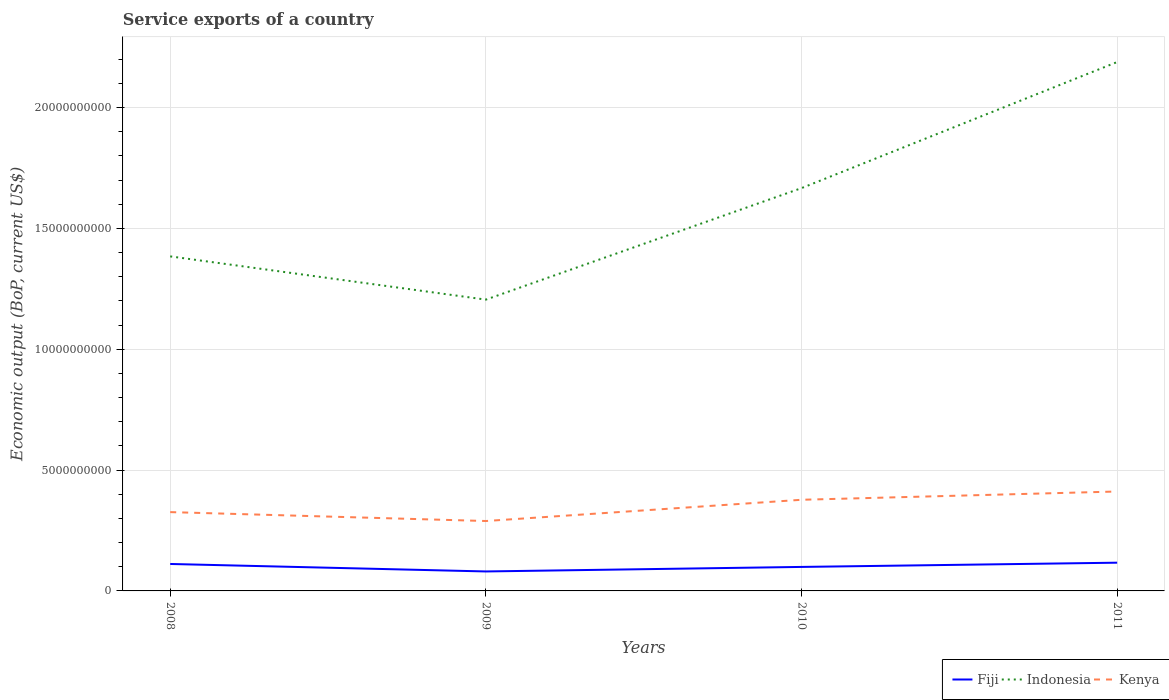Across all years, what is the maximum service exports in Indonesia?
Make the answer very short. 1.21e+1. In which year was the service exports in Kenya maximum?
Give a very brief answer. 2009. What is the total service exports in Fiji in the graph?
Provide a short and direct response. 3.09e+08. What is the difference between the highest and the second highest service exports in Fiji?
Your answer should be compact. 3.63e+08. What is the difference between two consecutive major ticks on the Y-axis?
Provide a short and direct response. 5.00e+09. How many legend labels are there?
Keep it short and to the point. 3. How are the legend labels stacked?
Give a very brief answer. Horizontal. What is the title of the graph?
Make the answer very short. Service exports of a country. Does "Nigeria" appear as one of the legend labels in the graph?
Your answer should be compact. No. What is the label or title of the X-axis?
Offer a terse response. Years. What is the label or title of the Y-axis?
Provide a succinct answer. Economic output (BoP, current US$). What is the Economic output (BoP, current US$) of Fiji in 2008?
Your answer should be compact. 1.12e+09. What is the Economic output (BoP, current US$) of Indonesia in 2008?
Your answer should be compact. 1.38e+1. What is the Economic output (BoP, current US$) of Kenya in 2008?
Give a very brief answer. 3.26e+09. What is the Economic output (BoP, current US$) of Fiji in 2009?
Offer a very short reply. 8.06e+08. What is the Economic output (BoP, current US$) of Indonesia in 2009?
Your answer should be compact. 1.21e+1. What is the Economic output (BoP, current US$) in Kenya in 2009?
Ensure brevity in your answer.  2.89e+09. What is the Economic output (BoP, current US$) in Fiji in 2010?
Keep it short and to the point. 9.93e+08. What is the Economic output (BoP, current US$) in Indonesia in 2010?
Offer a very short reply. 1.67e+1. What is the Economic output (BoP, current US$) in Kenya in 2010?
Offer a terse response. 3.77e+09. What is the Economic output (BoP, current US$) of Fiji in 2011?
Offer a terse response. 1.17e+09. What is the Economic output (BoP, current US$) of Indonesia in 2011?
Make the answer very short. 2.19e+1. What is the Economic output (BoP, current US$) in Kenya in 2011?
Your answer should be compact. 4.11e+09. Across all years, what is the maximum Economic output (BoP, current US$) of Fiji?
Your answer should be very brief. 1.17e+09. Across all years, what is the maximum Economic output (BoP, current US$) of Indonesia?
Give a very brief answer. 2.19e+1. Across all years, what is the maximum Economic output (BoP, current US$) in Kenya?
Provide a short and direct response. 4.11e+09. Across all years, what is the minimum Economic output (BoP, current US$) in Fiji?
Make the answer very short. 8.06e+08. Across all years, what is the minimum Economic output (BoP, current US$) in Indonesia?
Keep it short and to the point. 1.21e+1. Across all years, what is the minimum Economic output (BoP, current US$) of Kenya?
Provide a succinct answer. 2.89e+09. What is the total Economic output (BoP, current US$) of Fiji in the graph?
Ensure brevity in your answer.  4.08e+09. What is the total Economic output (BoP, current US$) of Indonesia in the graph?
Offer a very short reply. 6.45e+1. What is the total Economic output (BoP, current US$) in Kenya in the graph?
Ensure brevity in your answer.  1.40e+1. What is the difference between the Economic output (BoP, current US$) of Fiji in 2008 and that in 2009?
Offer a terse response. 3.09e+08. What is the difference between the Economic output (BoP, current US$) of Indonesia in 2008 and that in 2009?
Provide a succinct answer. 1.79e+09. What is the difference between the Economic output (BoP, current US$) of Kenya in 2008 and that in 2009?
Your answer should be very brief. 3.69e+08. What is the difference between the Economic output (BoP, current US$) of Fiji in 2008 and that in 2010?
Provide a short and direct response. 1.22e+08. What is the difference between the Economic output (BoP, current US$) in Indonesia in 2008 and that in 2010?
Provide a succinct answer. -2.83e+09. What is the difference between the Economic output (BoP, current US$) of Kenya in 2008 and that in 2010?
Offer a terse response. -5.10e+08. What is the difference between the Economic output (BoP, current US$) in Fiji in 2008 and that in 2011?
Ensure brevity in your answer.  -5.33e+07. What is the difference between the Economic output (BoP, current US$) in Indonesia in 2008 and that in 2011?
Offer a very short reply. -8.04e+09. What is the difference between the Economic output (BoP, current US$) in Kenya in 2008 and that in 2011?
Your response must be concise. -8.53e+08. What is the difference between the Economic output (BoP, current US$) of Fiji in 2009 and that in 2010?
Provide a short and direct response. -1.88e+08. What is the difference between the Economic output (BoP, current US$) in Indonesia in 2009 and that in 2010?
Ensure brevity in your answer.  -4.61e+09. What is the difference between the Economic output (BoP, current US$) in Kenya in 2009 and that in 2010?
Keep it short and to the point. -8.79e+08. What is the difference between the Economic output (BoP, current US$) of Fiji in 2009 and that in 2011?
Provide a succinct answer. -3.63e+08. What is the difference between the Economic output (BoP, current US$) in Indonesia in 2009 and that in 2011?
Ensure brevity in your answer.  -9.83e+09. What is the difference between the Economic output (BoP, current US$) in Kenya in 2009 and that in 2011?
Your answer should be very brief. -1.22e+09. What is the difference between the Economic output (BoP, current US$) of Fiji in 2010 and that in 2011?
Your answer should be very brief. -1.75e+08. What is the difference between the Economic output (BoP, current US$) in Indonesia in 2010 and that in 2011?
Your answer should be compact. -5.22e+09. What is the difference between the Economic output (BoP, current US$) in Kenya in 2010 and that in 2011?
Your response must be concise. -3.42e+08. What is the difference between the Economic output (BoP, current US$) of Fiji in 2008 and the Economic output (BoP, current US$) of Indonesia in 2009?
Provide a succinct answer. -1.09e+1. What is the difference between the Economic output (BoP, current US$) of Fiji in 2008 and the Economic output (BoP, current US$) of Kenya in 2009?
Make the answer very short. -1.78e+09. What is the difference between the Economic output (BoP, current US$) of Indonesia in 2008 and the Economic output (BoP, current US$) of Kenya in 2009?
Keep it short and to the point. 1.10e+1. What is the difference between the Economic output (BoP, current US$) of Fiji in 2008 and the Economic output (BoP, current US$) of Indonesia in 2010?
Make the answer very short. -1.56e+1. What is the difference between the Economic output (BoP, current US$) in Fiji in 2008 and the Economic output (BoP, current US$) in Kenya in 2010?
Your answer should be compact. -2.66e+09. What is the difference between the Economic output (BoP, current US$) in Indonesia in 2008 and the Economic output (BoP, current US$) in Kenya in 2010?
Make the answer very short. 1.01e+1. What is the difference between the Economic output (BoP, current US$) in Fiji in 2008 and the Economic output (BoP, current US$) in Indonesia in 2011?
Offer a terse response. -2.08e+1. What is the difference between the Economic output (BoP, current US$) in Fiji in 2008 and the Economic output (BoP, current US$) in Kenya in 2011?
Your response must be concise. -3.00e+09. What is the difference between the Economic output (BoP, current US$) of Indonesia in 2008 and the Economic output (BoP, current US$) of Kenya in 2011?
Ensure brevity in your answer.  9.73e+09. What is the difference between the Economic output (BoP, current US$) of Fiji in 2009 and the Economic output (BoP, current US$) of Indonesia in 2010?
Your answer should be compact. -1.59e+1. What is the difference between the Economic output (BoP, current US$) of Fiji in 2009 and the Economic output (BoP, current US$) of Kenya in 2010?
Offer a very short reply. -2.97e+09. What is the difference between the Economic output (BoP, current US$) of Indonesia in 2009 and the Economic output (BoP, current US$) of Kenya in 2010?
Provide a succinct answer. 8.28e+09. What is the difference between the Economic output (BoP, current US$) of Fiji in 2009 and the Economic output (BoP, current US$) of Indonesia in 2011?
Your answer should be very brief. -2.11e+1. What is the difference between the Economic output (BoP, current US$) of Fiji in 2009 and the Economic output (BoP, current US$) of Kenya in 2011?
Offer a very short reply. -3.31e+09. What is the difference between the Economic output (BoP, current US$) in Indonesia in 2009 and the Economic output (BoP, current US$) in Kenya in 2011?
Provide a succinct answer. 7.94e+09. What is the difference between the Economic output (BoP, current US$) in Fiji in 2010 and the Economic output (BoP, current US$) in Indonesia in 2011?
Your answer should be compact. -2.09e+1. What is the difference between the Economic output (BoP, current US$) in Fiji in 2010 and the Economic output (BoP, current US$) in Kenya in 2011?
Offer a terse response. -3.12e+09. What is the difference between the Economic output (BoP, current US$) of Indonesia in 2010 and the Economic output (BoP, current US$) of Kenya in 2011?
Your answer should be very brief. 1.26e+1. What is the average Economic output (BoP, current US$) of Fiji per year?
Provide a succinct answer. 1.02e+09. What is the average Economic output (BoP, current US$) in Indonesia per year?
Provide a short and direct response. 1.61e+1. What is the average Economic output (BoP, current US$) in Kenya per year?
Your answer should be compact. 3.51e+09. In the year 2008, what is the difference between the Economic output (BoP, current US$) in Fiji and Economic output (BoP, current US$) in Indonesia?
Keep it short and to the point. -1.27e+1. In the year 2008, what is the difference between the Economic output (BoP, current US$) of Fiji and Economic output (BoP, current US$) of Kenya?
Provide a succinct answer. -2.15e+09. In the year 2008, what is the difference between the Economic output (BoP, current US$) in Indonesia and Economic output (BoP, current US$) in Kenya?
Offer a very short reply. 1.06e+1. In the year 2009, what is the difference between the Economic output (BoP, current US$) in Fiji and Economic output (BoP, current US$) in Indonesia?
Provide a short and direct response. -1.12e+1. In the year 2009, what is the difference between the Economic output (BoP, current US$) in Fiji and Economic output (BoP, current US$) in Kenya?
Ensure brevity in your answer.  -2.09e+09. In the year 2009, what is the difference between the Economic output (BoP, current US$) of Indonesia and Economic output (BoP, current US$) of Kenya?
Your answer should be compact. 9.16e+09. In the year 2010, what is the difference between the Economic output (BoP, current US$) in Fiji and Economic output (BoP, current US$) in Indonesia?
Offer a terse response. -1.57e+1. In the year 2010, what is the difference between the Economic output (BoP, current US$) in Fiji and Economic output (BoP, current US$) in Kenya?
Your answer should be compact. -2.78e+09. In the year 2010, what is the difference between the Economic output (BoP, current US$) in Indonesia and Economic output (BoP, current US$) in Kenya?
Ensure brevity in your answer.  1.29e+1. In the year 2011, what is the difference between the Economic output (BoP, current US$) in Fiji and Economic output (BoP, current US$) in Indonesia?
Give a very brief answer. -2.07e+1. In the year 2011, what is the difference between the Economic output (BoP, current US$) in Fiji and Economic output (BoP, current US$) in Kenya?
Provide a short and direct response. -2.95e+09. In the year 2011, what is the difference between the Economic output (BoP, current US$) in Indonesia and Economic output (BoP, current US$) in Kenya?
Your answer should be very brief. 1.78e+1. What is the ratio of the Economic output (BoP, current US$) of Fiji in 2008 to that in 2009?
Make the answer very short. 1.38. What is the ratio of the Economic output (BoP, current US$) in Indonesia in 2008 to that in 2009?
Make the answer very short. 1.15. What is the ratio of the Economic output (BoP, current US$) in Kenya in 2008 to that in 2009?
Provide a short and direct response. 1.13. What is the ratio of the Economic output (BoP, current US$) in Fiji in 2008 to that in 2010?
Your answer should be compact. 1.12. What is the ratio of the Economic output (BoP, current US$) of Indonesia in 2008 to that in 2010?
Make the answer very short. 0.83. What is the ratio of the Economic output (BoP, current US$) of Kenya in 2008 to that in 2010?
Give a very brief answer. 0.86. What is the ratio of the Economic output (BoP, current US$) of Fiji in 2008 to that in 2011?
Your answer should be compact. 0.95. What is the ratio of the Economic output (BoP, current US$) in Indonesia in 2008 to that in 2011?
Offer a very short reply. 0.63. What is the ratio of the Economic output (BoP, current US$) in Kenya in 2008 to that in 2011?
Ensure brevity in your answer.  0.79. What is the ratio of the Economic output (BoP, current US$) of Fiji in 2009 to that in 2010?
Your answer should be compact. 0.81. What is the ratio of the Economic output (BoP, current US$) of Indonesia in 2009 to that in 2010?
Make the answer very short. 0.72. What is the ratio of the Economic output (BoP, current US$) in Kenya in 2009 to that in 2010?
Your answer should be very brief. 0.77. What is the ratio of the Economic output (BoP, current US$) of Fiji in 2009 to that in 2011?
Your answer should be very brief. 0.69. What is the ratio of the Economic output (BoP, current US$) in Indonesia in 2009 to that in 2011?
Give a very brief answer. 0.55. What is the ratio of the Economic output (BoP, current US$) of Kenya in 2009 to that in 2011?
Your answer should be very brief. 0.7. What is the ratio of the Economic output (BoP, current US$) in Fiji in 2010 to that in 2011?
Provide a short and direct response. 0.85. What is the ratio of the Economic output (BoP, current US$) of Indonesia in 2010 to that in 2011?
Your answer should be very brief. 0.76. What is the ratio of the Economic output (BoP, current US$) of Kenya in 2010 to that in 2011?
Keep it short and to the point. 0.92. What is the difference between the highest and the second highest Economic output (BoP, current US$) of Fiji?
Your response must be concise. 5.33e+07. What is the difference between the highest and the second highest Economic output (BoP, current US$) of Indonesia?
Provide a short and direct response. 5.22e+09. What is the difference between the highest and the second highest Economic output (BoP, current US$) in Kenya?
Give a very brief answer. 3.42e+08. What is the difference between the highest and the lowest Economic output (BoP, current US$) of Fiji?
Offer a terse response. 3.63e+08. What is the difference between the highest and the lowest Economic output (BoP, current US$) in Indonesia?
Offer a very short reply. 9.83e+09. What is the difference between the highest and the lowest Economic output (BoP, current US$) of Kenya?
Keep it short and to the point. 1.22e+09. 